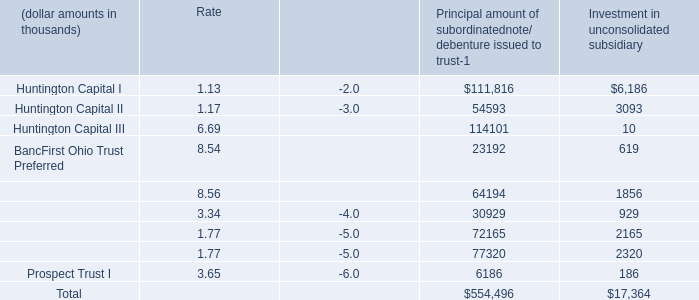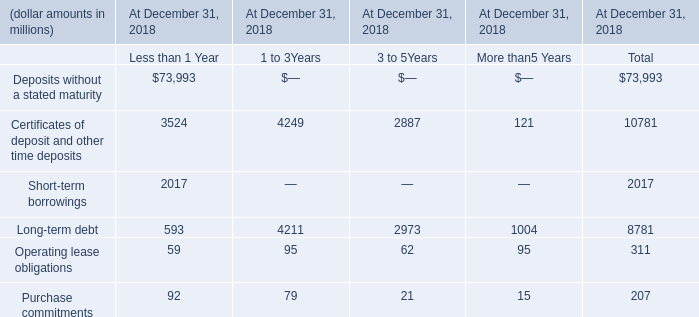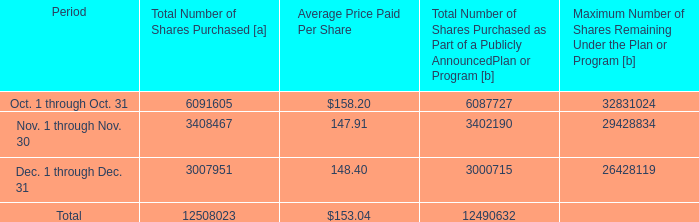what was the total cost of share repurchases , in millions , during 2018? 
Computations: ((57669746 / 1000000) * 143.70)
Answer: 8287.1425. 